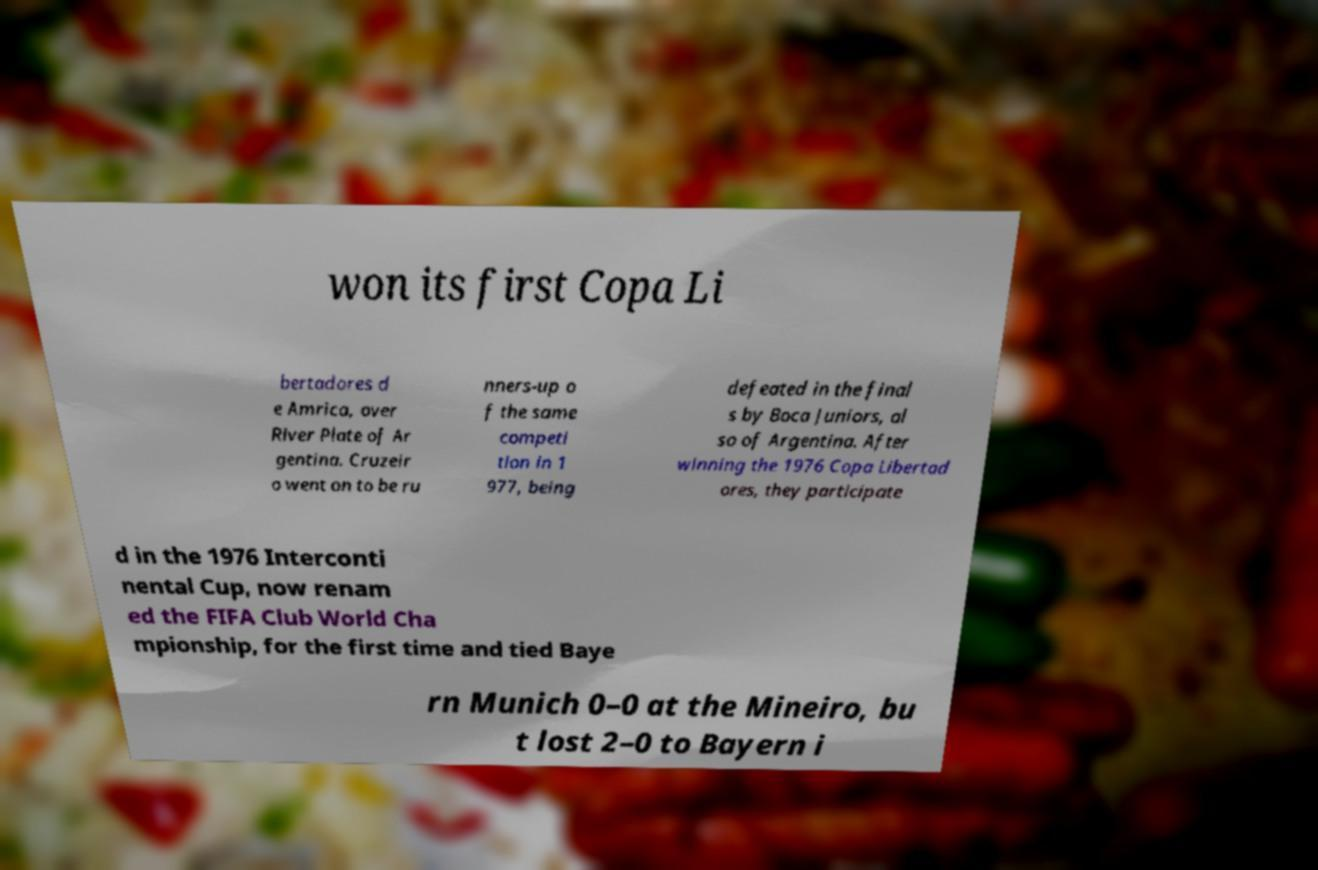There's text embedded in this image that I need extracted. Can you transcribe it verbatim? won its first Copa Li bertadores d e Amrica, over River Plate of Ar gentina. Cruzeir o went on to be ru nners-up o f the same competi tion in 1 977, being defeated in the final s by Boca Juniors, al so of Argentina. After winning the 1976 Copa Libertad ores, they participate d in the 1976 Interconti nental Cup, now renam ed the FIFA Club World Cha mpionship, for the first time and tied Baye rn Munich 0–0 at the Mineiro, bu t lost 2–0 to Bayern i 